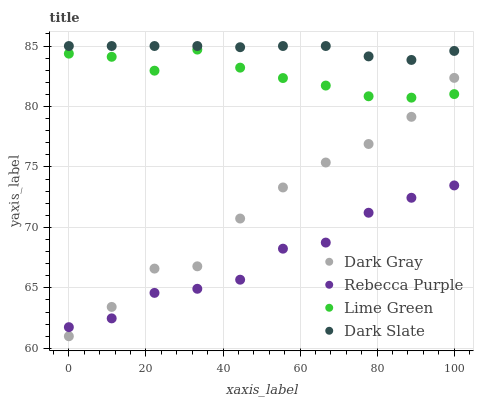Does Rebecca Purple have the minimum area under the curve?
Answer yes or no. Yes. Does Dark Slate have the maximum area under the curve?
Answer yes or no. Yes. Does Lime Green have the minimum area under the curve?
Answer yes or no. No. Does Lime Green have the maximum area under the curve?
Answer yes or no. No. Is Dark Slate the smoothest?
Answer yes or no. Yes. Is Dark Gray the roughest?
Answer yes or no. Yes. Is Lime Green the smoothest?
Answer yes or no. No. Is Lime Green the roughest?
Answer yes or no. No. Does Dark Gray have the lowest value?
Answer yes or no. Yes. Does Lime Green have the lowest value?
Answer yes or no. No. Does Dark Slate have the highest value?
Answer yes or no. Yes. Does Lime Green have the highest value?
Answer yes or no. No. Is Rebecca Purple less than Dark Slate?
Answer yes or no. Yes. Is Dark Slate greater than Lime Green?
Answer yes or no. Yes. Does Dark Gray intersect Lime Green?
Answer yes or no. Yes. Is Dark Gray less than Lime Green?
Answer yes or no. No. Is Dark Gray greater than Lime Green?
Answer yes or no. No. Does Rebecca Purple intersect Dark Slate?
Answer yes or no. No. 